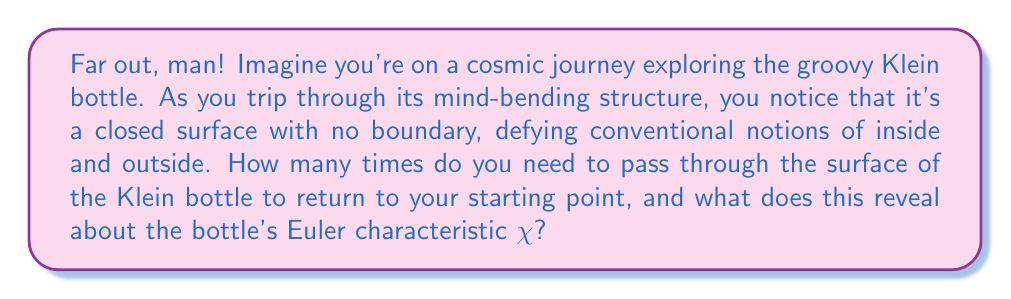Give your solution to this math problem. Alright, let's dive into this far-out exploration of the Klein bottle, dude!

1) First, we need to understand what a Klein bottle is. It's a non-orientable surface that has no inside or outside. It's like a cosmic loop that twists back on itself in a higher dimension.

2) When we travel on the surface of a Klein bottle, we can pass through it without ever leaving its surface. This is because the Klein bottle intersects with itself in a way that allows continuous motion.

3) To return to our starting point, we need to make two complete passes through the surface. This is because:
   - On the first pass, we end up on the "other side" of the surface.
   - On the second pass, we return to our original side and starting point.

4) Now, let's connect this to the Euler characteristic $\chi$. The Euler characteristic is a topological invariant that describes the shape's structure regardless of how it's bent or stretched.

5) For a Klein bottle, the Euler characteristic is zero: $\chi = 0$

6) We can understand this by looking at a polygonal representation of a Klein bottle:
   - It has 1 face (the entire surface)
   - 2 edges (which are identified in pairs)
   - 1 vertex (all corners are identified)

7) Using the formula $\chi = V - E + F$, where V is vertices, E is edges, and F is faces:
   $\chi = 1 - 2 + 1 = 0$

8) This zero Euler characteristic is related to the fact that we need two passes to return to our starting point. It indicates that the Klein bottle is a closed surface with no boundary, balancing its "positive" and "negative" curvature in a cosmic harmony.

9) The connection to non-conformist thinking is in how the Klein bottle challenges our conventional notions of inside and outside, much like how counterculture challenges societal norms. It represents a continuity and interconnectedness that transcends simple dualities.
Answer: You need to pass through the surface of the Klein bottle twice to return to your starting point. This is related to its Euler characteristic $\chi = 0$, which indicates a closed, boundary-free surface that balances its curvature in a way that defies conventional spatial intuition. 